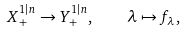<formula> <loc_0><loc_0><loc_500><loc_500>X _ { + } ^ { 1 | n } \rightarrow Y ^ { 1 | n } _ { + } , \quad \lambda \mapsto f _ { \lambda } ,</formula> 